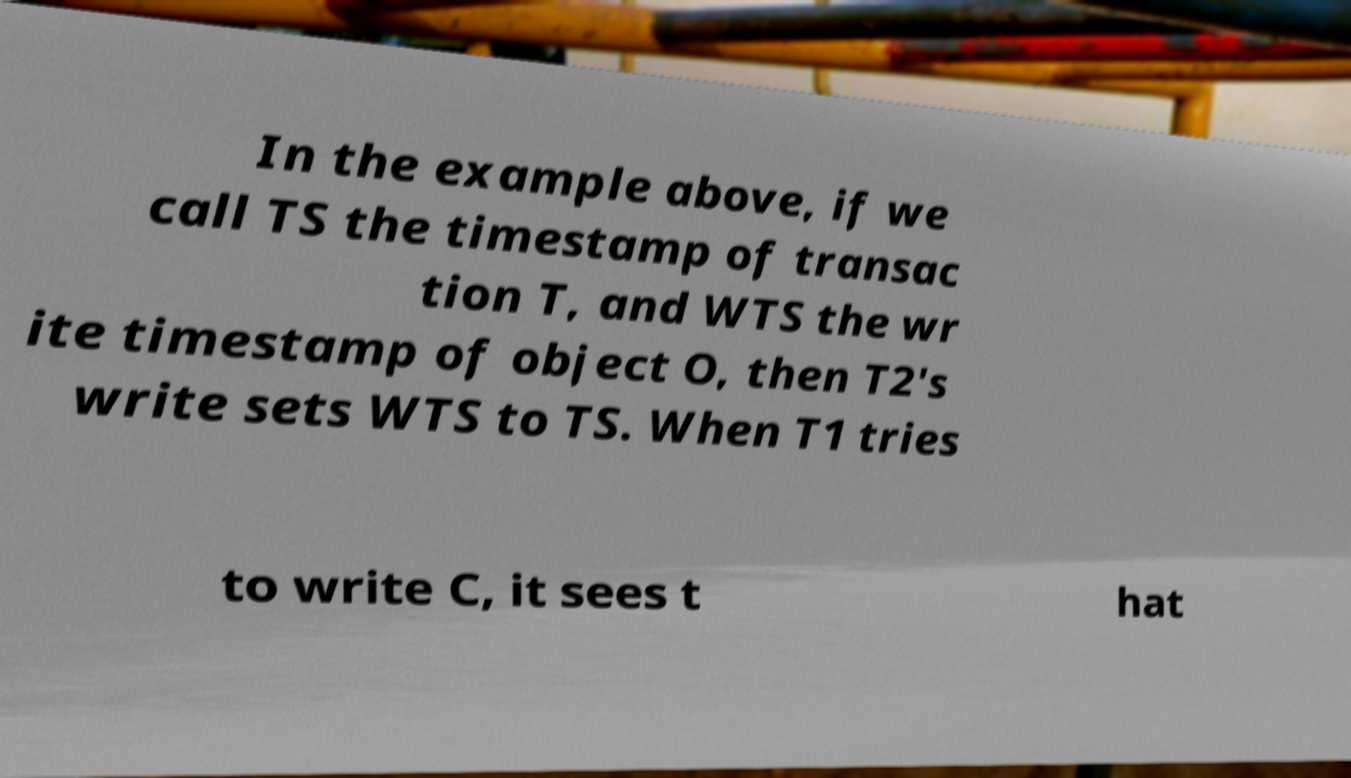There's text embedded in this image that I need extracted. Can you transcribe it verbatim? In the example above, if we call TS the timestamp of transac tion T, and WTS the wr ite timestamp of object O, then T2's write sets WTS to TS. When T1 tries to write C, it sees t hat 